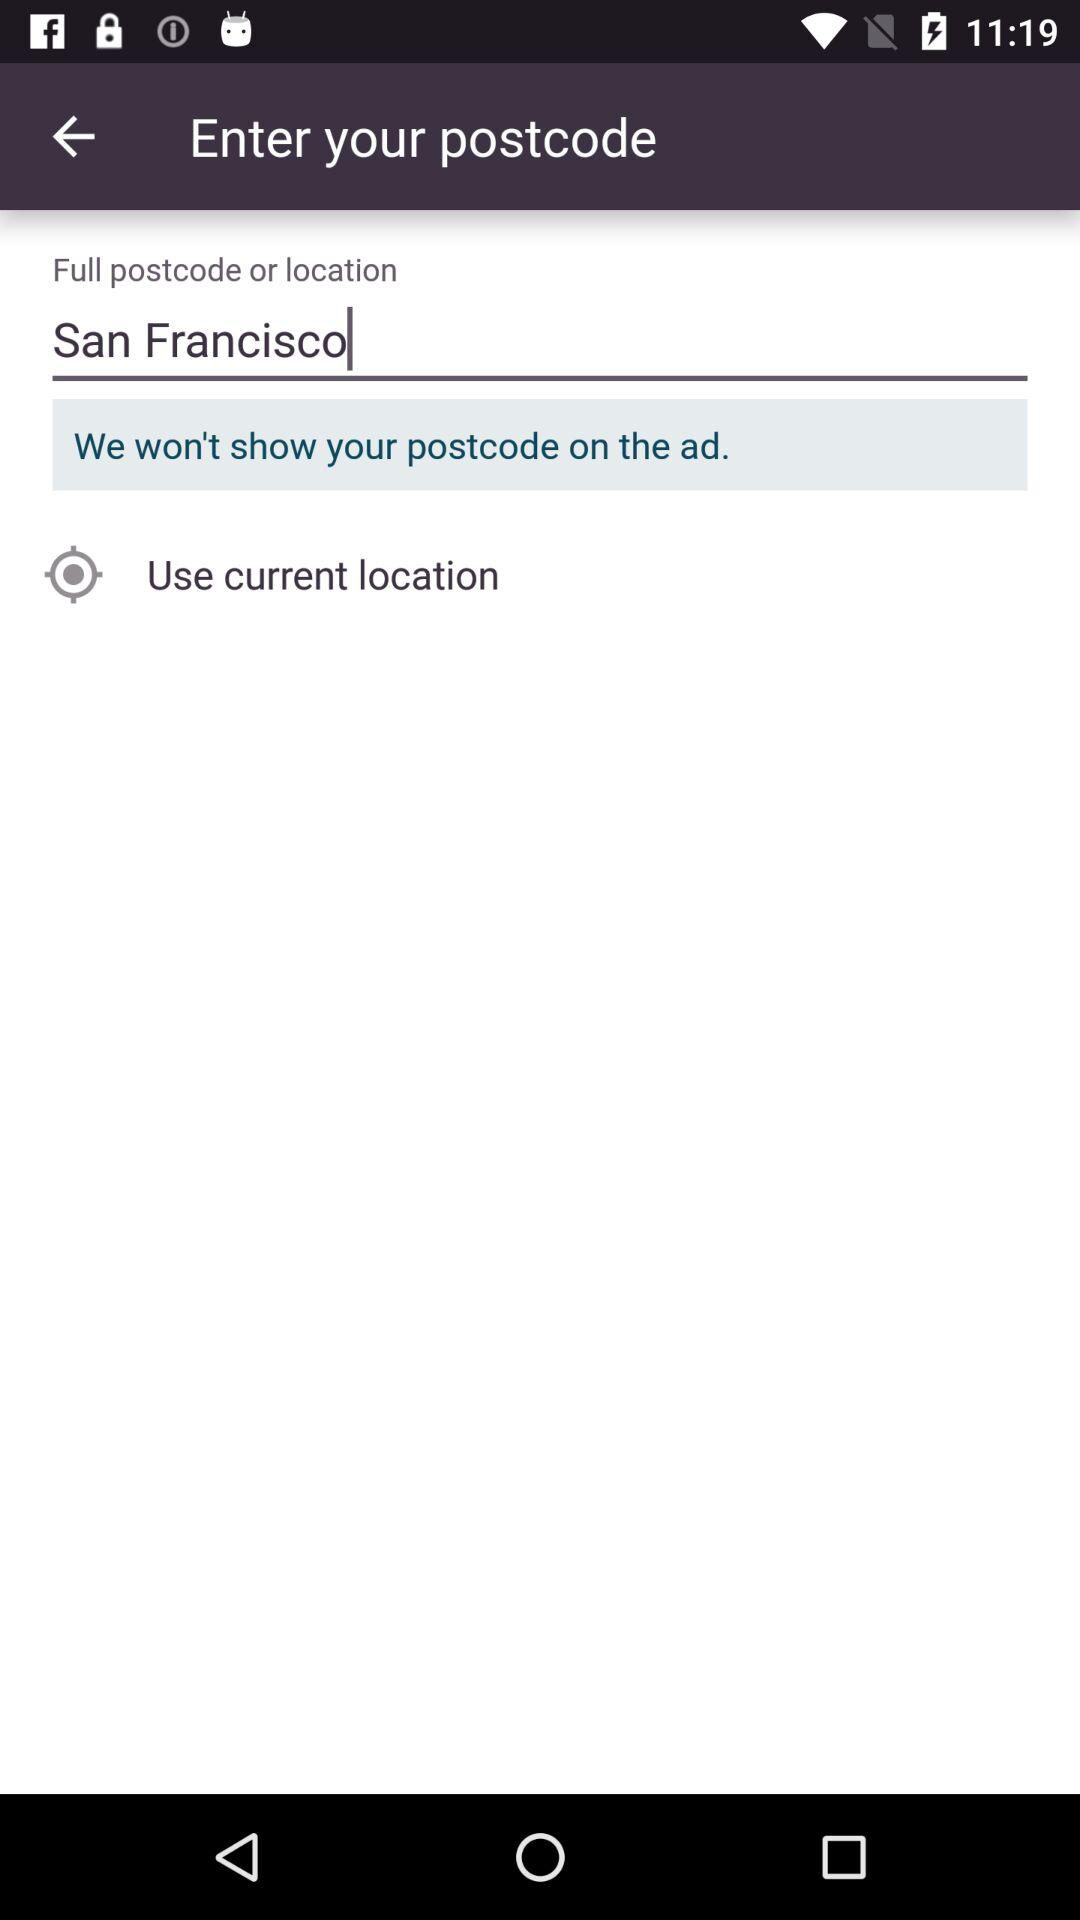What is the location? The location is San Francisco. 